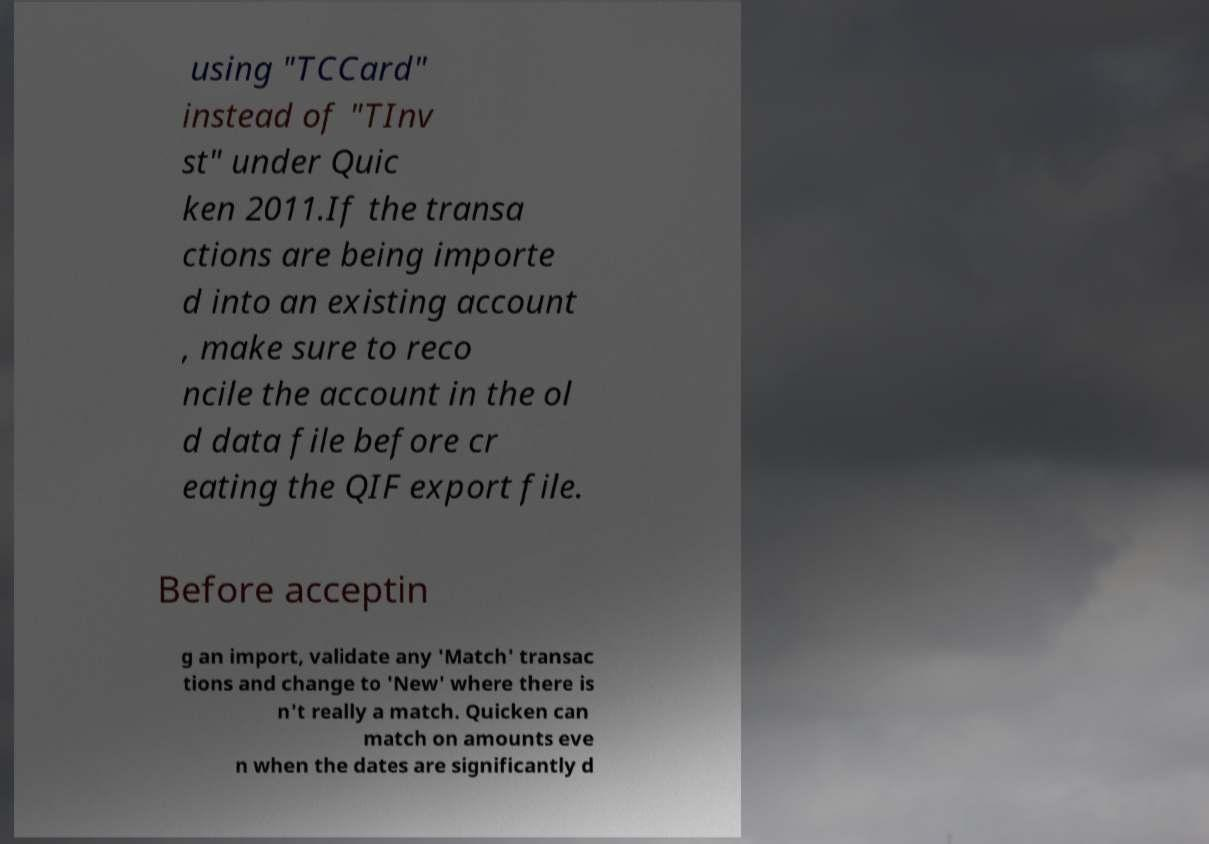Please identify and transcribe the text found in this image. using "TCCard" instead of "TInv st" under Quic ken 2011.If the transa ctions are being importe d into an existing account , make sure to reco ncile the account in the ol d data file before cr eating the QIF export file. Before acceptin g an import, validate any 'Match' transac tions and change to 'New' where there is n't really a match. Quicken can match on amounts eve n when the dates are significantly d 